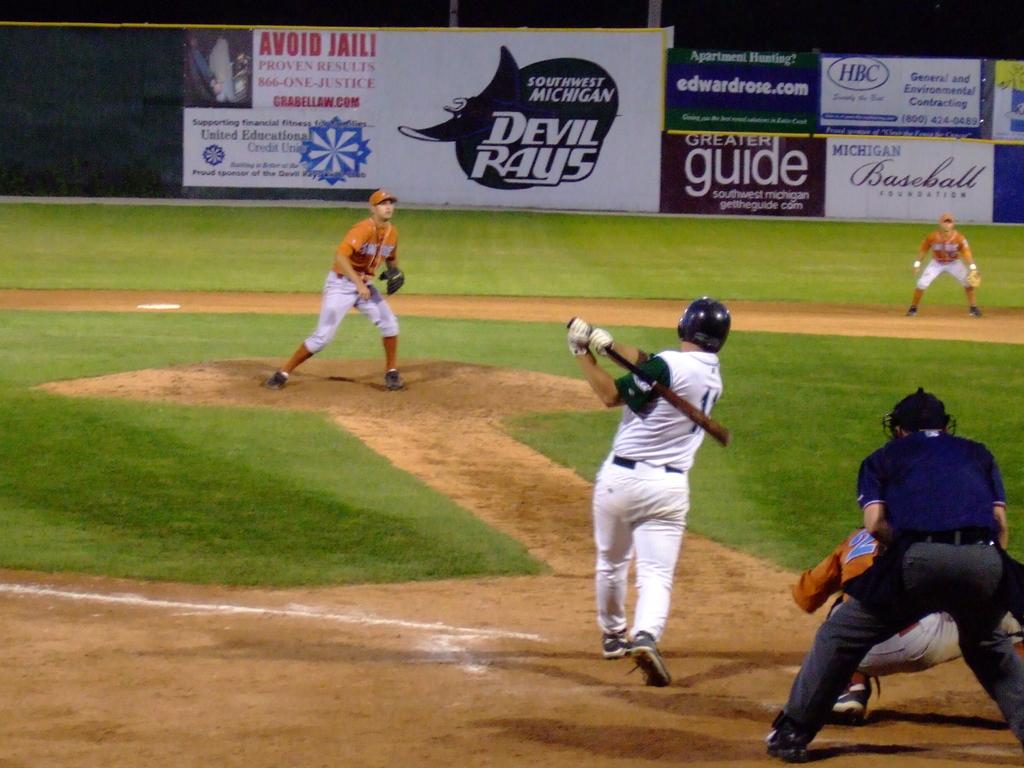What should you avoid according to the sign in the upper left?
Keep it short and to the point. Jail. 